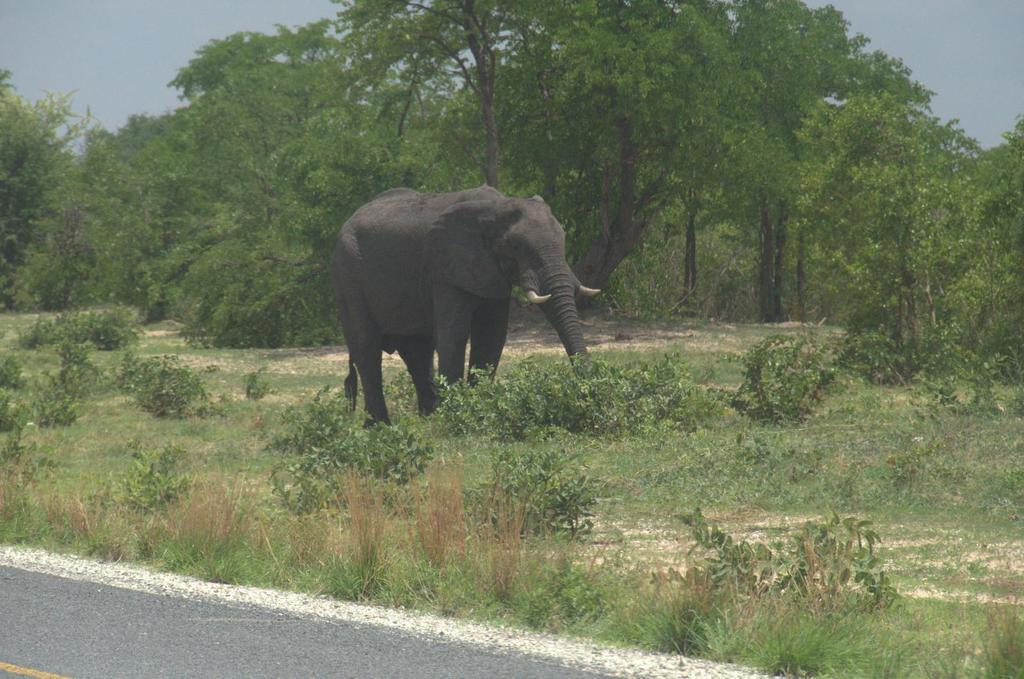What is the color of the elephant in the image? The elephant in the image is black in color. What can be seen in the background of the image? There are trees visible in the background of the image. What type of vegetation is present in the image? There is green grass in the image. What is the color of the sky in the image? The sky is blue in color. What type of chalk is the elephant using to draw in the image? There is no chalk or drawing activity present in the image; it features an elephant standing amidst trees and grass. 